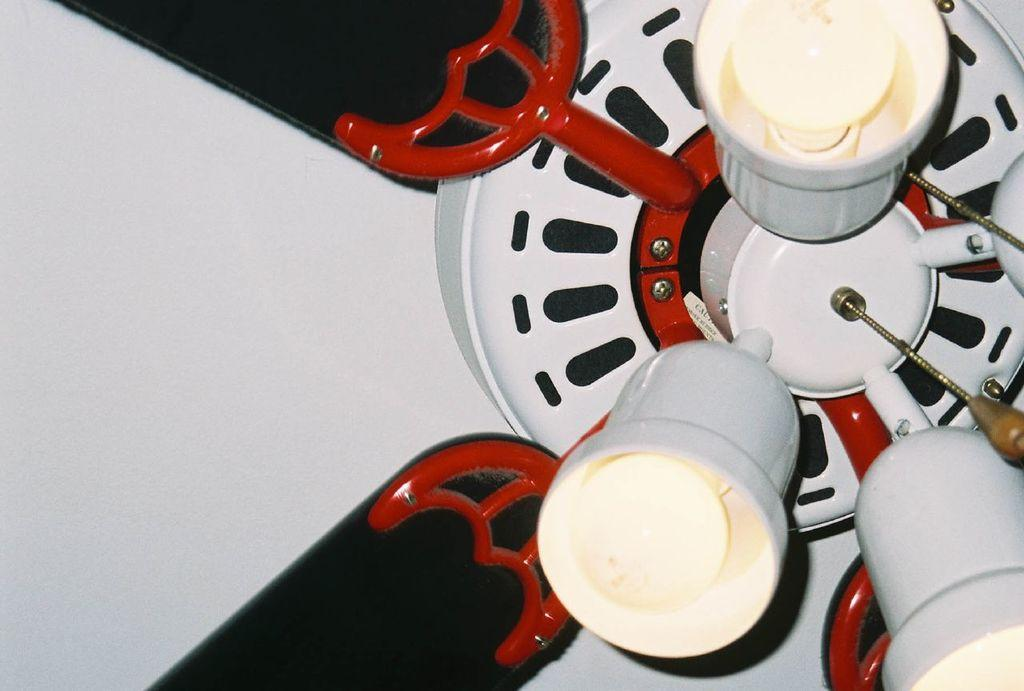What type of decorative object is present in the image? There is a decorative ceiling fan in the image. What feature does the ceiling fan have? The ceiling fan has lights. What type of berry is hanging from the ceiling fan in the image? There are no berries present in the image; the ceiling fan has lights, not berries. 